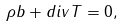Convert formula to latex. <formula><loc_0><loc_0><loc_500><loc_500>\rho b + d i v T = 0 ,</formula> 